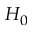Convert formula to latex. <formula><loc_0><loc_0><loc_500><loc_500>H _ { 0 }</formula> 